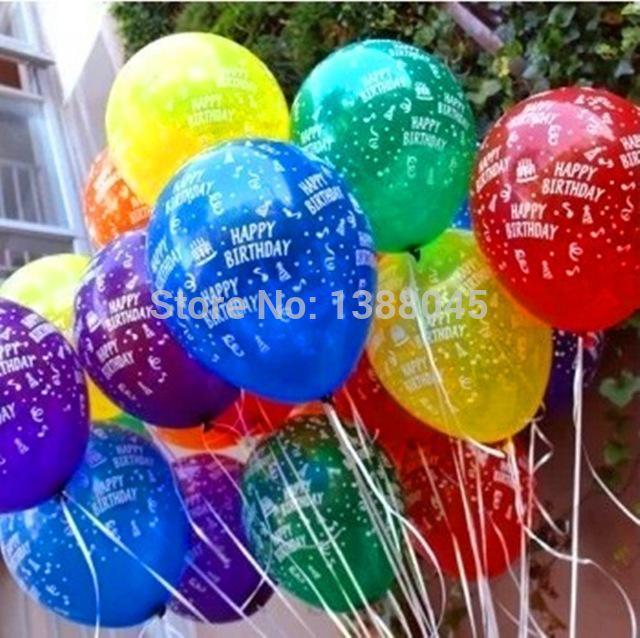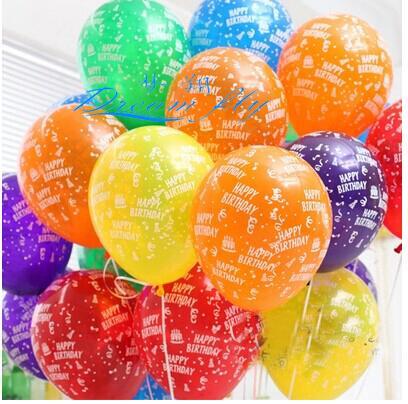The first image is the image on the left, the second image is the image on the right. Given the left and right images, does the statement "In at least one image there are hundreds of balloons being released into the sky." hold true? Answer yes or no. No. 